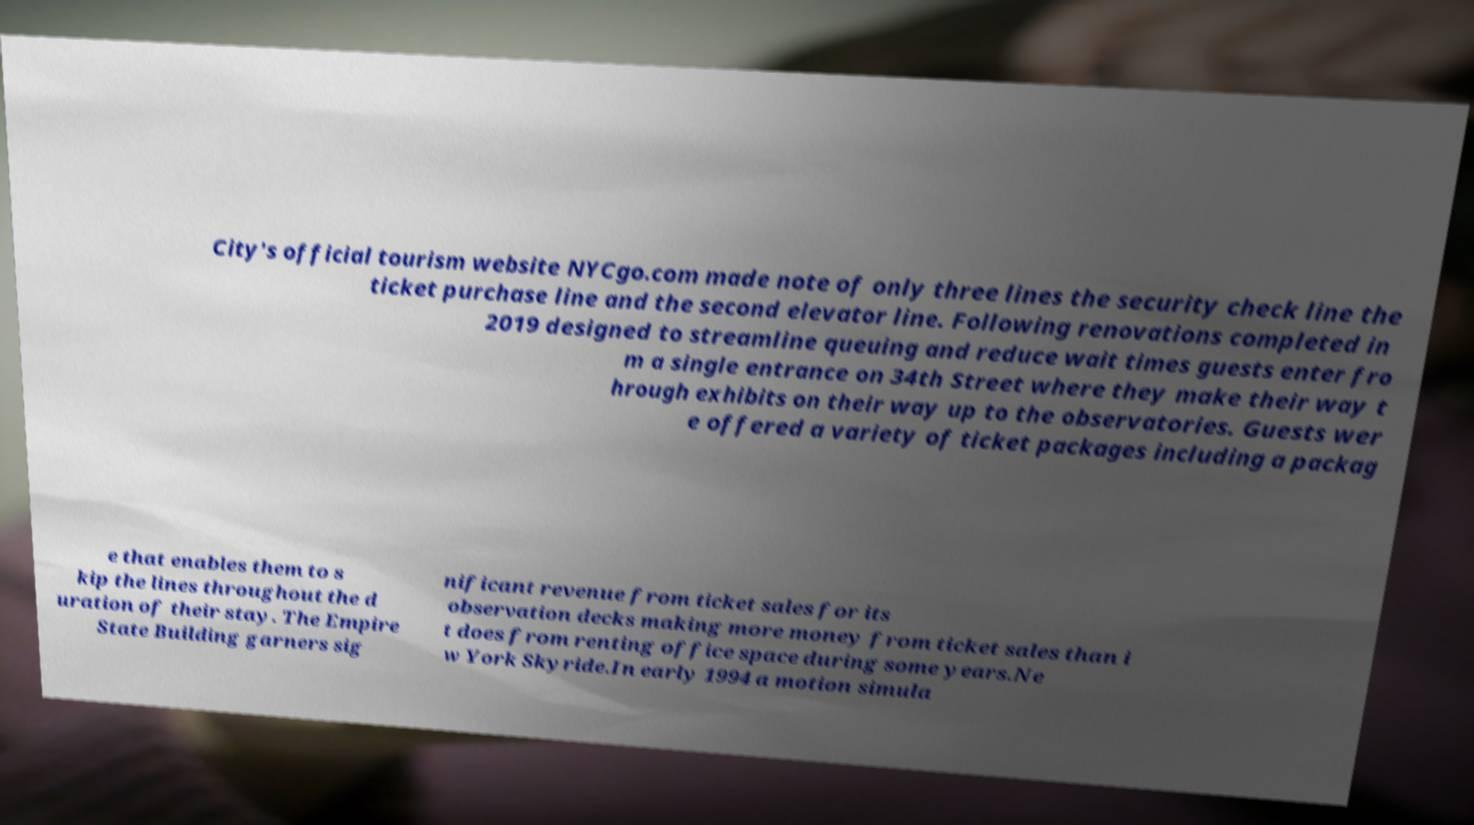For documentation purposes, I need the text within this image transcribed. Could you provide that? City's official tourism website NYCgo.com made note of only three lines the security check line the ticket purchase line and the second elevator line. Following renovations completed in 2019 designed to streamline queuing and reduce wait times guests enter fro m a single entrance on 34th Street where they make their way t hrough exhibits on their way up to the observatories. Guests wer e offered a variety of ticket packages including a packag e that enables them to s kip the lines throughout the d uration of their stay. The Empire State Building garners sig nificant revenue from ticket sales for its observation decks making more money from ticket sales than i t does from renting office space during some years.Ne w York Skyride.In early 1994 a motion simula 